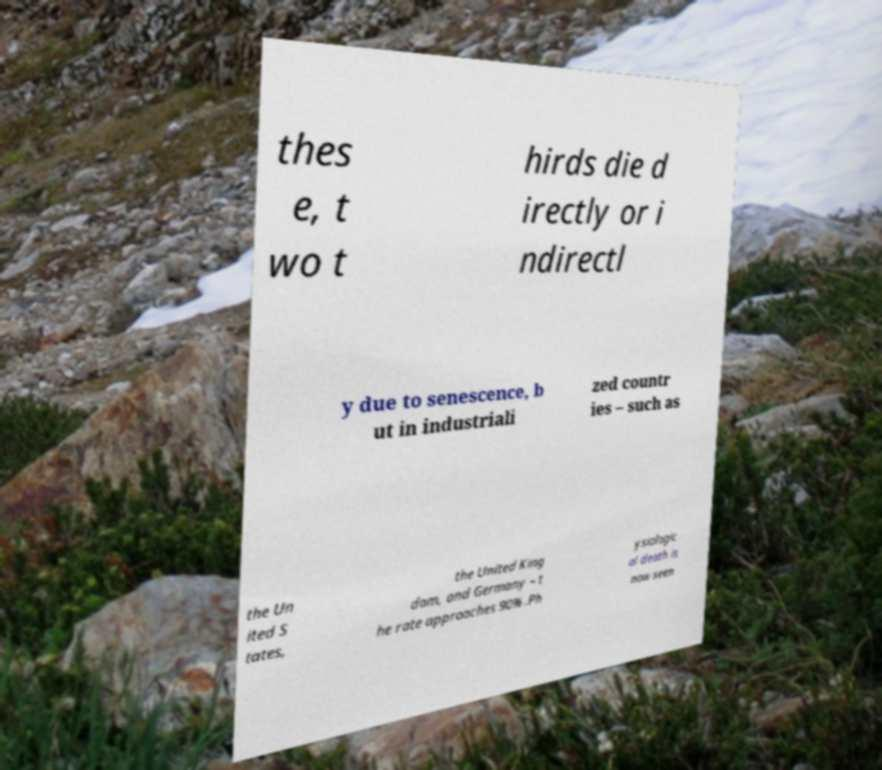Please identify and transcribe the text found in this image. thes e, t wo t hirds die d irectly or i ndirectl y due to senescence, b ut in industriali zed countr ies – such as the Un ited S tates, the United King dom, and Germany – t he rate approaches 90% .Ph ysiologic al death is now seen 